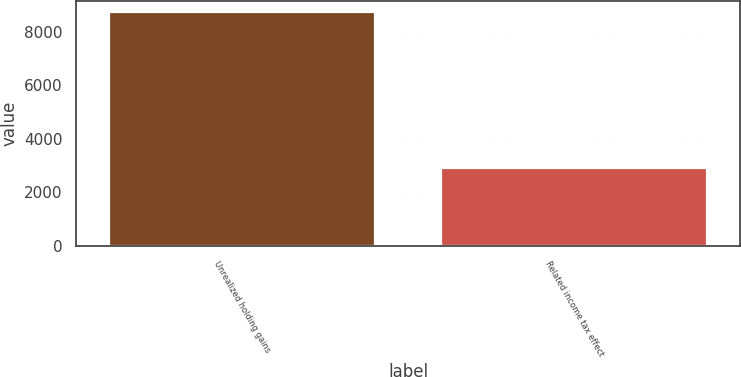<chart> <loc_0><loc_0><loc_500><loc_500><bar_chart><fcel>Unrealized holding gains<fcel>Related income tax effect<nl><fcel>8715<fcel>2911<nl></chart> 